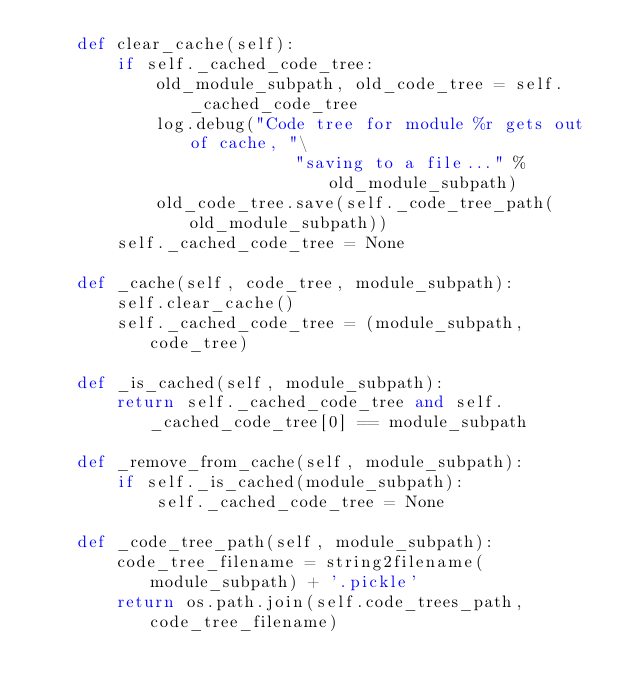Convert code to text. <code><loc_0><loc_0><loc_500><loc_500><_Python_>    def clear_cache(self):
        if self._cached_code_tree:
            old_module_subpath, old_code_tree = self._cached_code_tree
            log.debug("Code tree for module %r gets out of cache, "\
                          "saving to a file..." %  old_module_subpath)
            old_code_tree.save(self._code_tree_path(old_module_subpath))
        self._cached_code_tree = None

    def _cache(self, code_tree, module_subpath):
        self.clear_cache()
        self._cached_code_tree = (module_subpath, code_tree)

    def _is_cached(self, module_subpath):
        return self._cached_code_tree and self._cached_code_tree[0] == module_subpath

    def _remove_from_cache(self, module_subpath):
        if self._is_cached(module_subpath):
            self._cached_code_tree = None

    def _code_tree_path(self, module_subpath):
        code_tree_filename = string2filename(module_subpath) + '.pickle'
        return os.path.join(self.code_trees_path, code_tree_filename)
</code> 